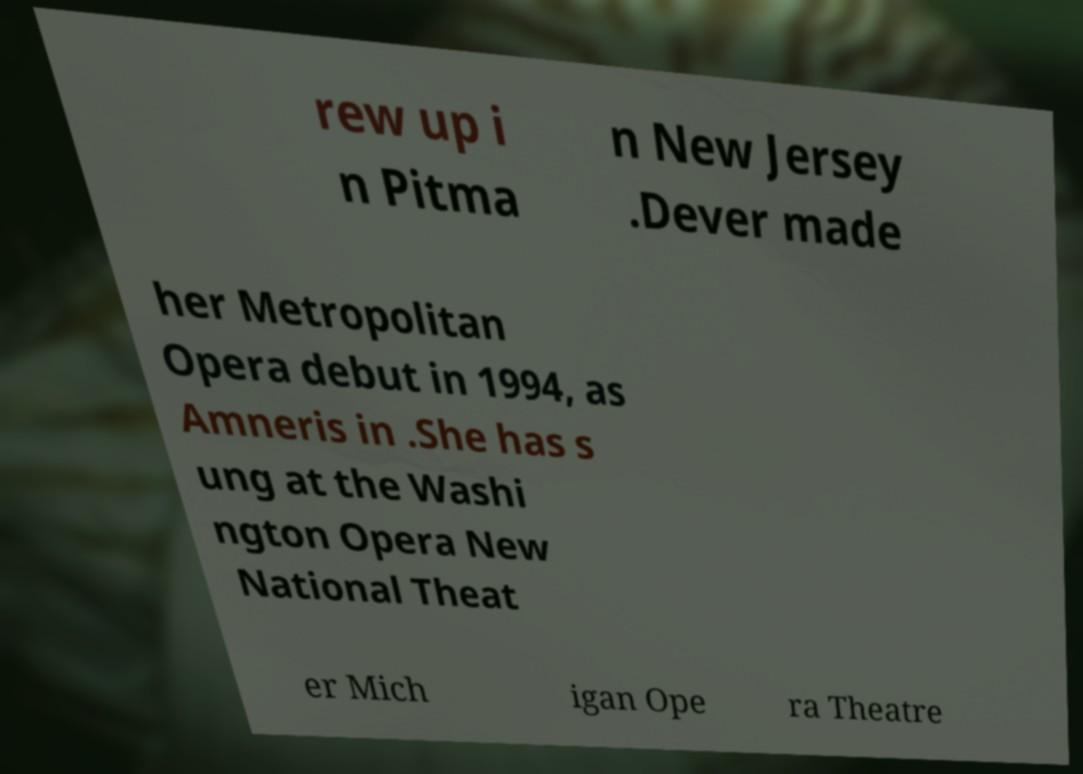Could you extract and type out the text from this image? rew up i n Pitma n New Jersey .Dever made her Metropolitan Opera debut in 1994, as Amneris in .She has s ung at the Washi ngton Opera New National Theat er Mich igan Ope ra Theatre 